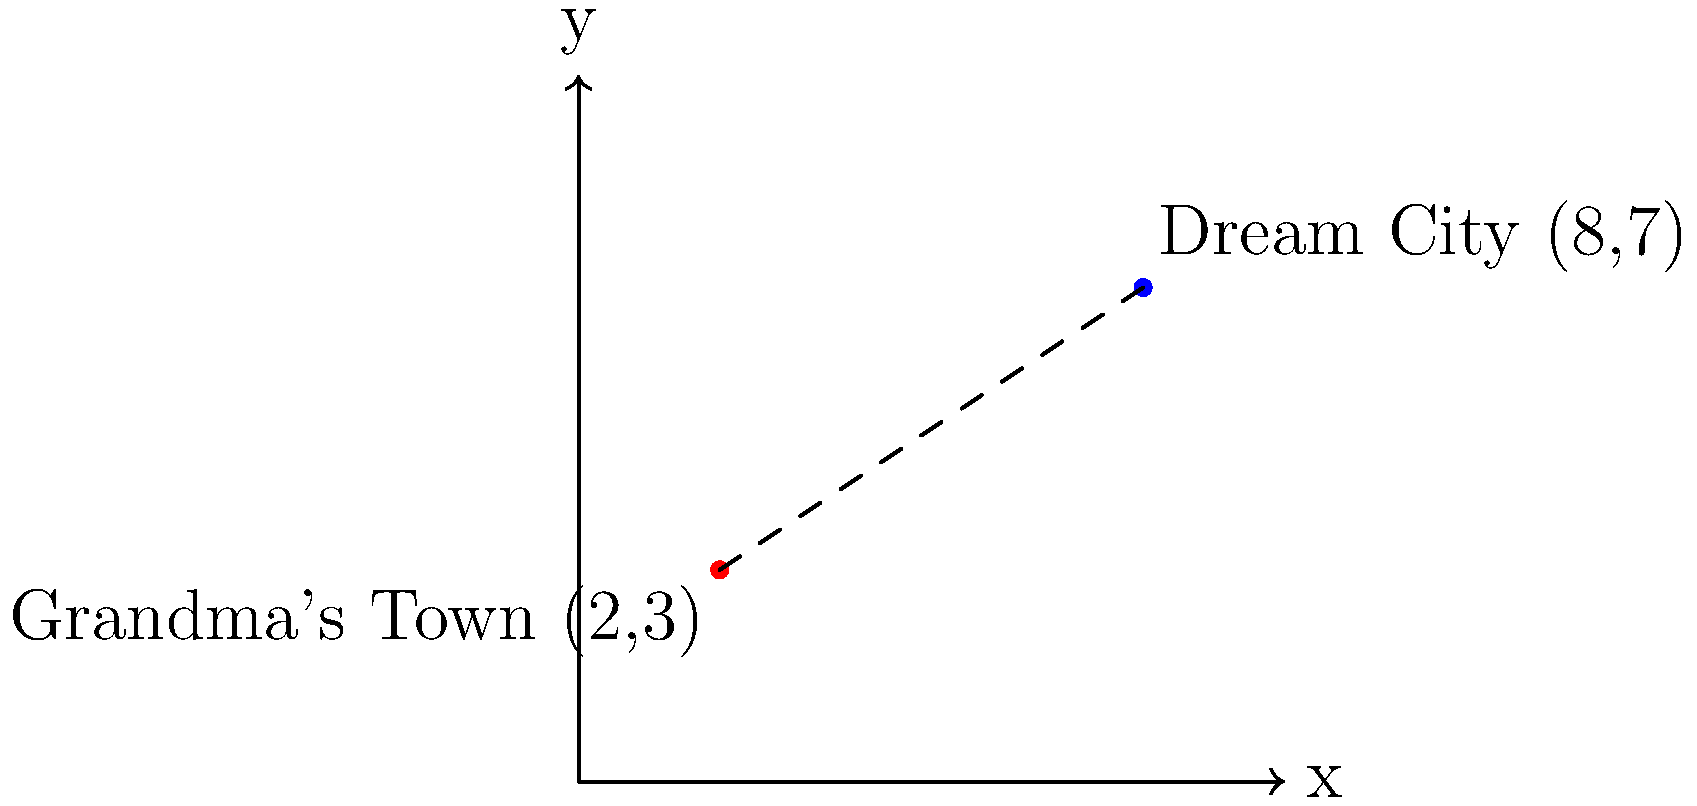Your grandmother shows you a map of her home country with two special locations marked: her hometown and a city she always dreamed of visiting. The map uses a coordinate system where each unit represents 50 kilometers. If her hometown is located at (2,3) and the dream city is at (8,7), how far apart are these two cities in kilometers? Let's solve this step-by-step:

1) We can use the distance formula to calculate the distance between two points. The formula is:

   $$d = \sqrt{(x_2-x_1)^2 + (y_2-y_1)^2}$$

   Where $(x_1,y_1)$ is the first point and $(x_2,y_2)$ is the second point.

2) In this case:
   $(x_1,y_1) = (2,3)$ (Grandma's hometown)
   $(x_2,y_2) = (8,7)$ (Dream city)

3) Let's plug these into the formula:

   $$d = \sqrt{(8-2)^2 + (7-3)^2}$$

4) Simplify inside the parentheses:

   $$d = \sqrt{6^2 + 4^2}$$

5) Calculate the squares:

   $$d = \sqrt{36 + 16}$$

6) Add inside the square root:

   $$d = \sqrt{52}$$

7) Simplify the square root:

   $$d = 2\sqrt{13}$$

8) This gives us the distance in units on the map. To convert to kilometers, we multiply by 50:

   $$\text{Distance in km} = 2\sqrt{13} * 50 = 100\sqrt{13} \approx 361.25 \text{ km}$$
Answer: $100\sqrt{13}$ km or approximately 361.25 km 